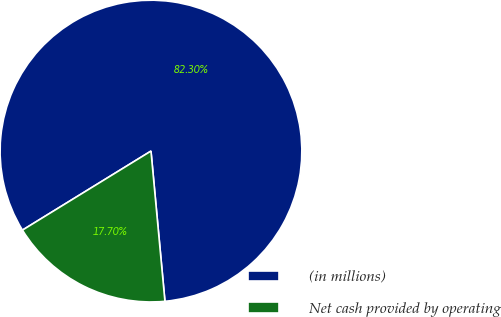Convert chart to OTSL. <chart><loc_0><loc_0><loc_500><loc_500><pie_chart><fcel>(in millions)<fcel>Net cash provided by operating<nl><fcel>82.3%<fcel>17.7%<nl></chart> 